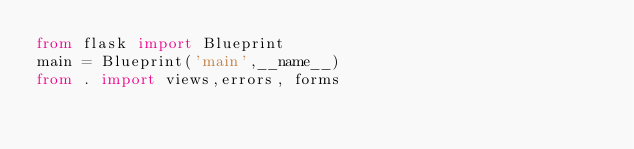<code> <loc_0><loc_0><loc_500><loc_500><_Python_>from flask import Blueprint
main = Blueprint('main',__name__)
from . import views,errors, forms</code> 